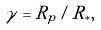Convert formula to latex. <formula><loc_0><loc_0><loc_500><loc_500>\gamma = R _ { p } / R _ { * } ,</formula> 